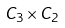Convert formula to latex. <formula><loc_0><loc_0><loc_500><loc_500>C _ { 3 } \times C _ { 2 }</formula> 